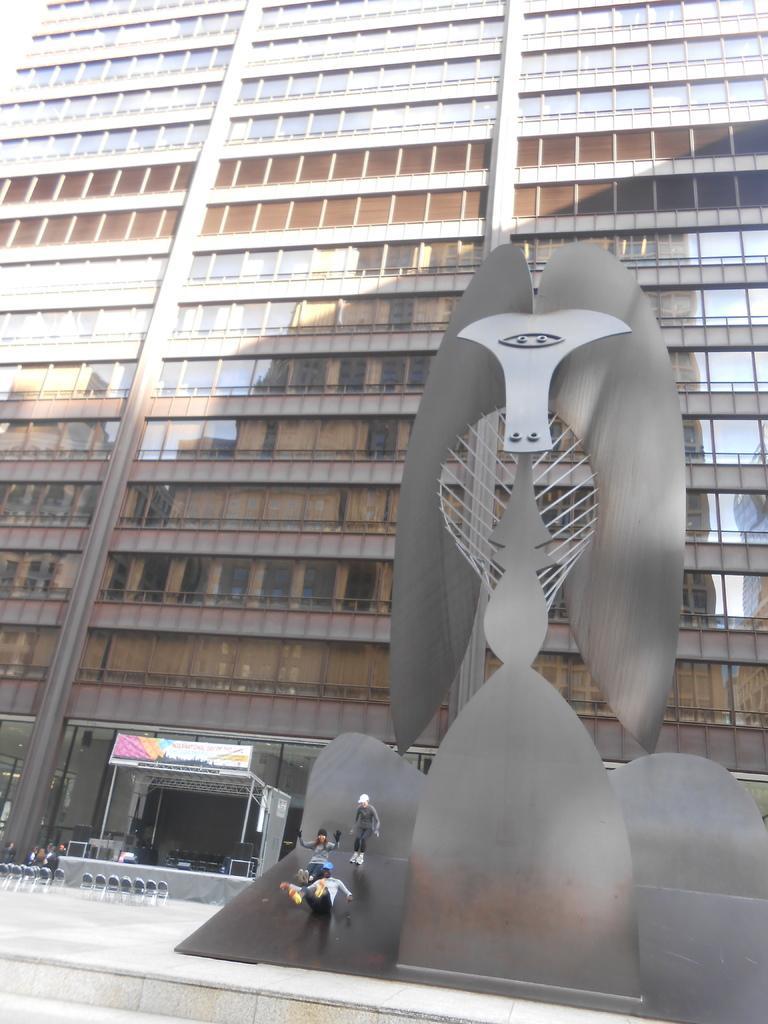Please provide a concise description of this image. In this picture there is a building. In the foreground there is a metal object and there are three people on the object. On the left side of the image there are chairs and there are speakers and chairs on the stage and there is a banner. At the bottom there is a pavement. At the top there is a reflection of a building on the mirrors and there is reflection of sky on the mirrors. 